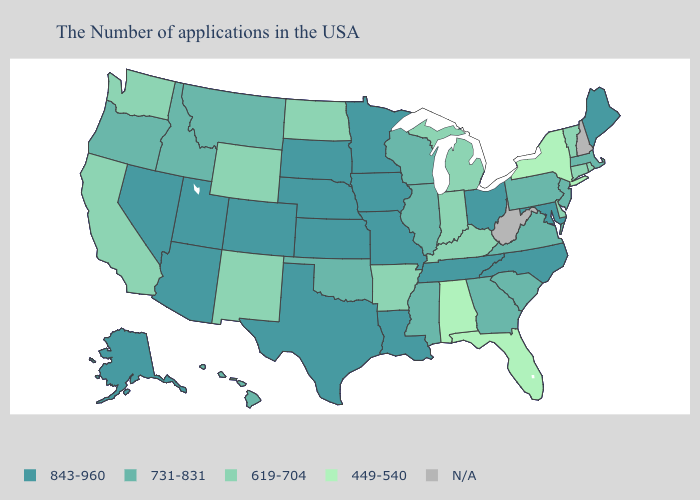Which states have the highest value in the USA?
Quick response, please. Maine, Maryland, North Carolina, Ohio, Tennessee, Louisiana, Missouri, Minnesota, Iowa, Kansas, Nebraska, Texas, South Dakota, Colorado, Utah, Arizona, Nevada, Alaska. What is the value of Wisconsin?
Short answer required. 731-831. Does the map have missing data?
Answer briefly. Yes. Is the legend a continuous bar?
Quick response, please. No. What is the value of North Dakota?
Keep it brief. 619-704. Does the first symbol in the legend represent the smallest category?
Give a very brief answer. No. What is the value of Wisconsin?
Answer briefly. 731-831. Name the states that have a value in the range 449-540?
Give a very brief answer. New York, Florida, Alabama. Name the states that have a value in the range 731-831?
Concise answer only. Massachusetts, New Jersey, Pennsylvania, Virginia, South Carolina, Georgia, Wisconsin, Illinois, Mississippi, Oklahoma, Montana, Idaho, Oregon, Hawaii. What is the value of Missouri?
Write a very short answer. 843-960. What is the value of Maine?
Concise answer only. 843-960. Among the states that border Arizona , does Colorado have the highest value?
Answer briefly. Yes. Name the states that have a value in the range 843-960?
Concise answer only. Maine, Maryland, North Carolina, Ohio, Tennessee, Louisiana, Missouri, Minnesota, Iowa, Kansas, Nebraska, Texas, South Dakota, Colorado, Utah, Arizona, Nevada, Alaska. 